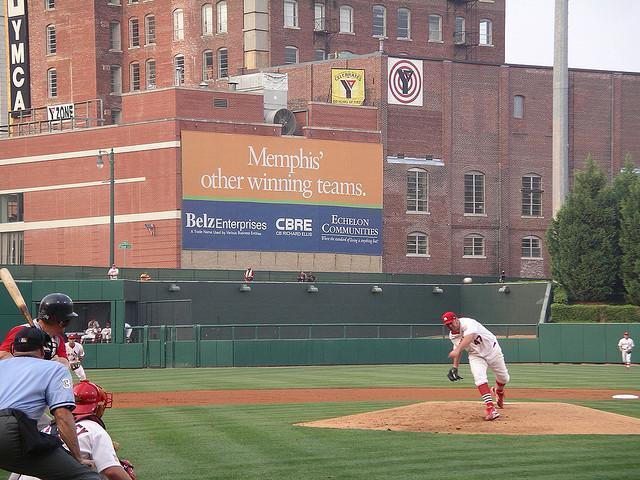How many people are visible?
Give a very brief answer. 3. How many fridge doors?
Give a very brief answer. 0. 